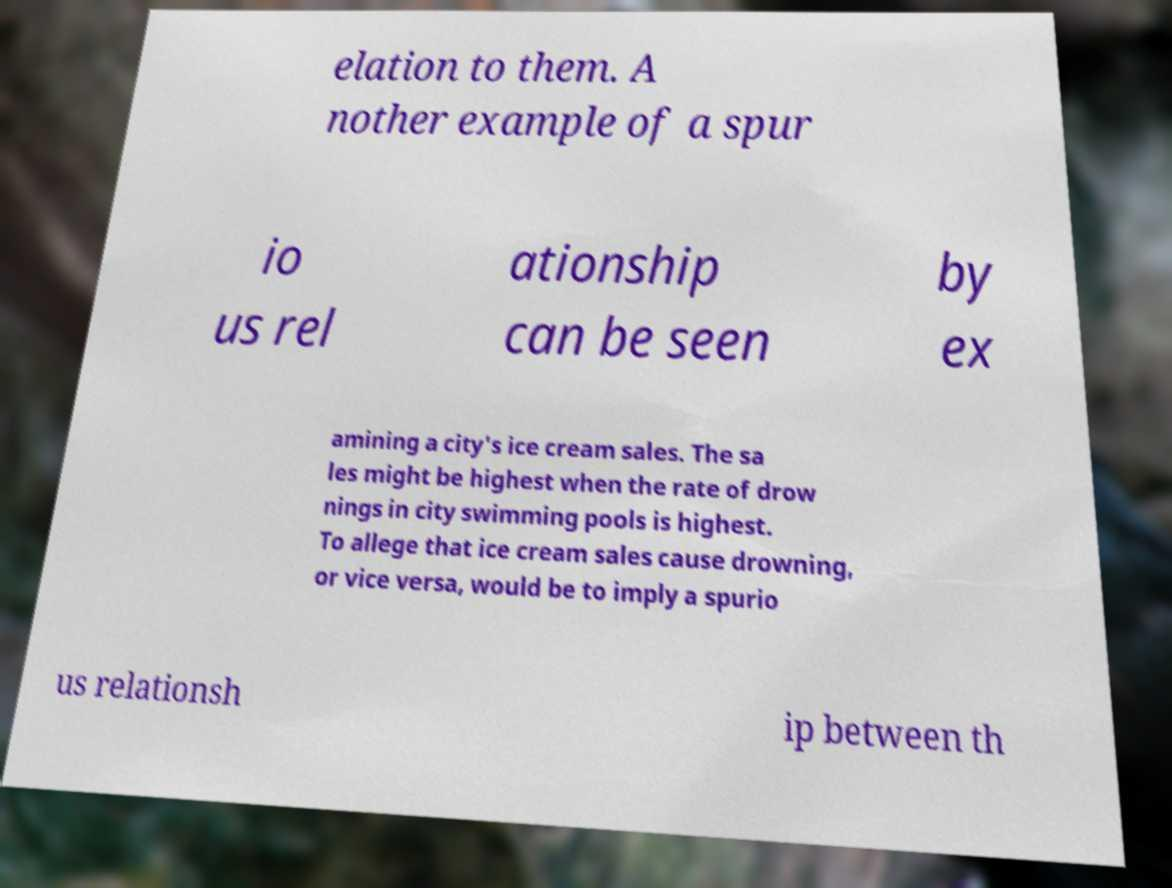There's text embedded in this image that I need extracted. Can you transcribe it verbatim? elation to them. A nother example of a spur io us rel ationship can be seen by ex amining a city's ice cream sales. The sa les might be highest when the rate of drow nings in city swimming pools is highest. To allege that ice cream sales cause drowning, or vice versa, would be to imply a spurio us relationsh ip between th 